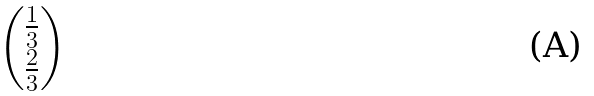Convert formula to latex. <formula><loc_0><loc_0><loc_500><loc_500>\begin{pmatrix} \frac { 1 } { 3 } \\ \frac { 2 } { 3 } \end{pmatrix}</formula> 